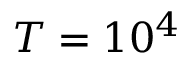Convert formula to latex. <formula><loc_0><loc_0><loc_500><loc_500>T = 1 0 ^ { 4 }</formula> 